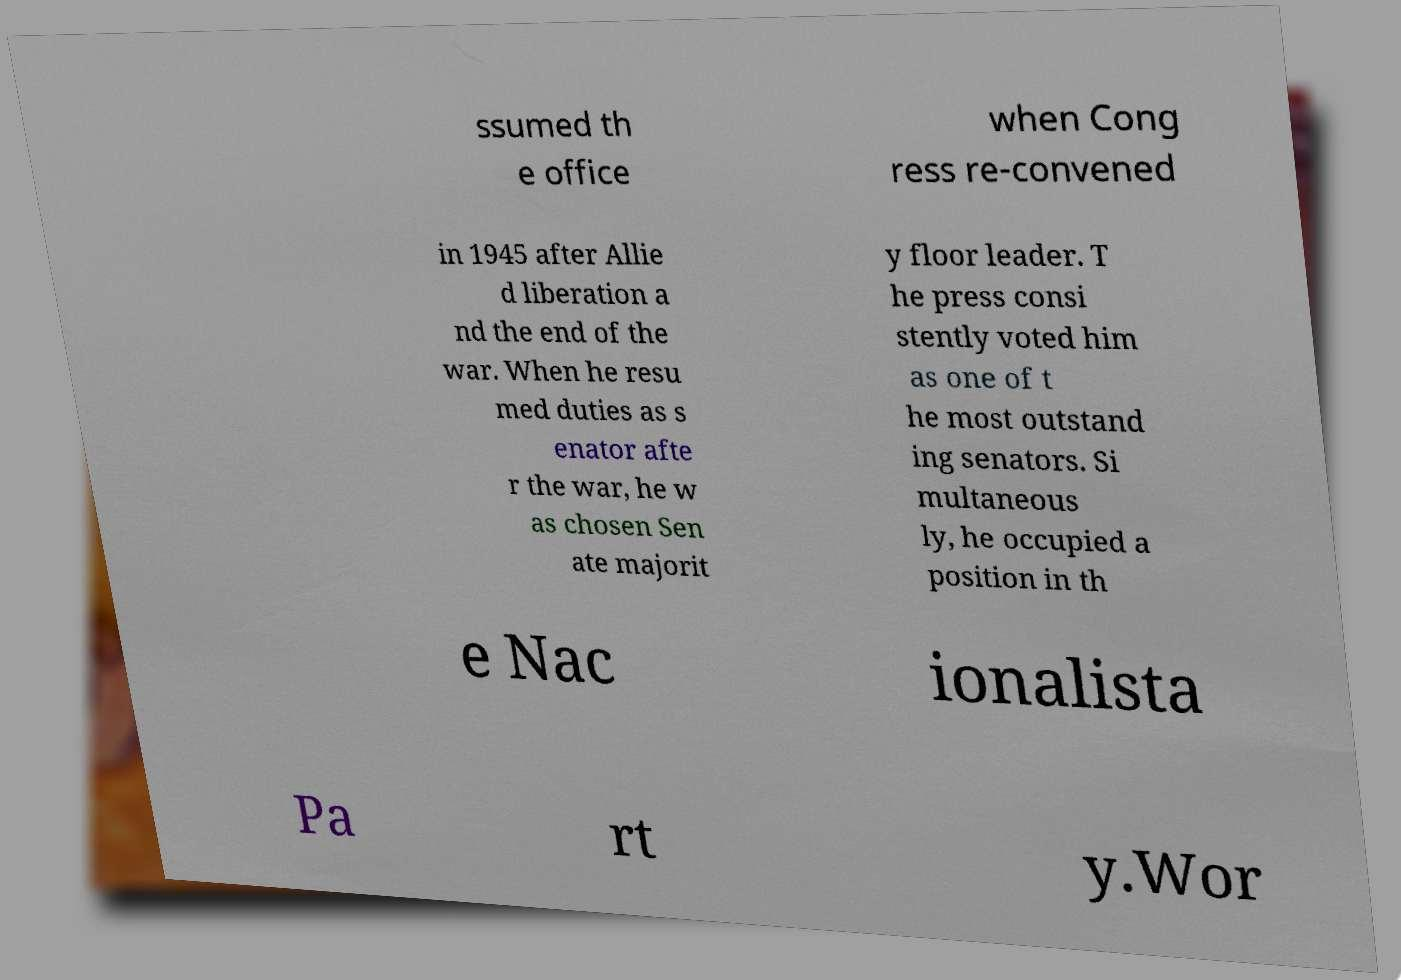Could you assist in decoding the text presented in this image and type it out clearly? ssumed th e office when Cong ress re-convened in 1945 after Allie d liberation a nd the end of the war. When he resu med duties as s enator afte r the war, he w as chosen Sen ate majorit y floor leader. T he press consi stently voted him as one of t he most outstand ing senators. Si multaneous ly, he occupied a position in th e Nac ionalista Pa rt y.Wor 